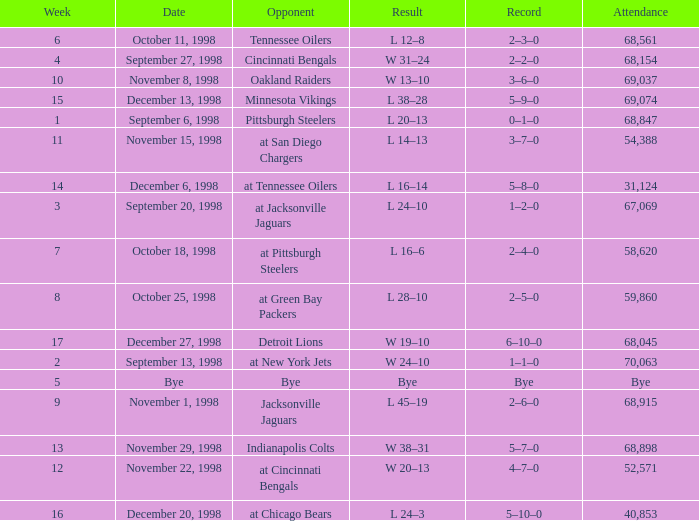What is the highest week that was played against the Minnesota Vikings? 15.0. 